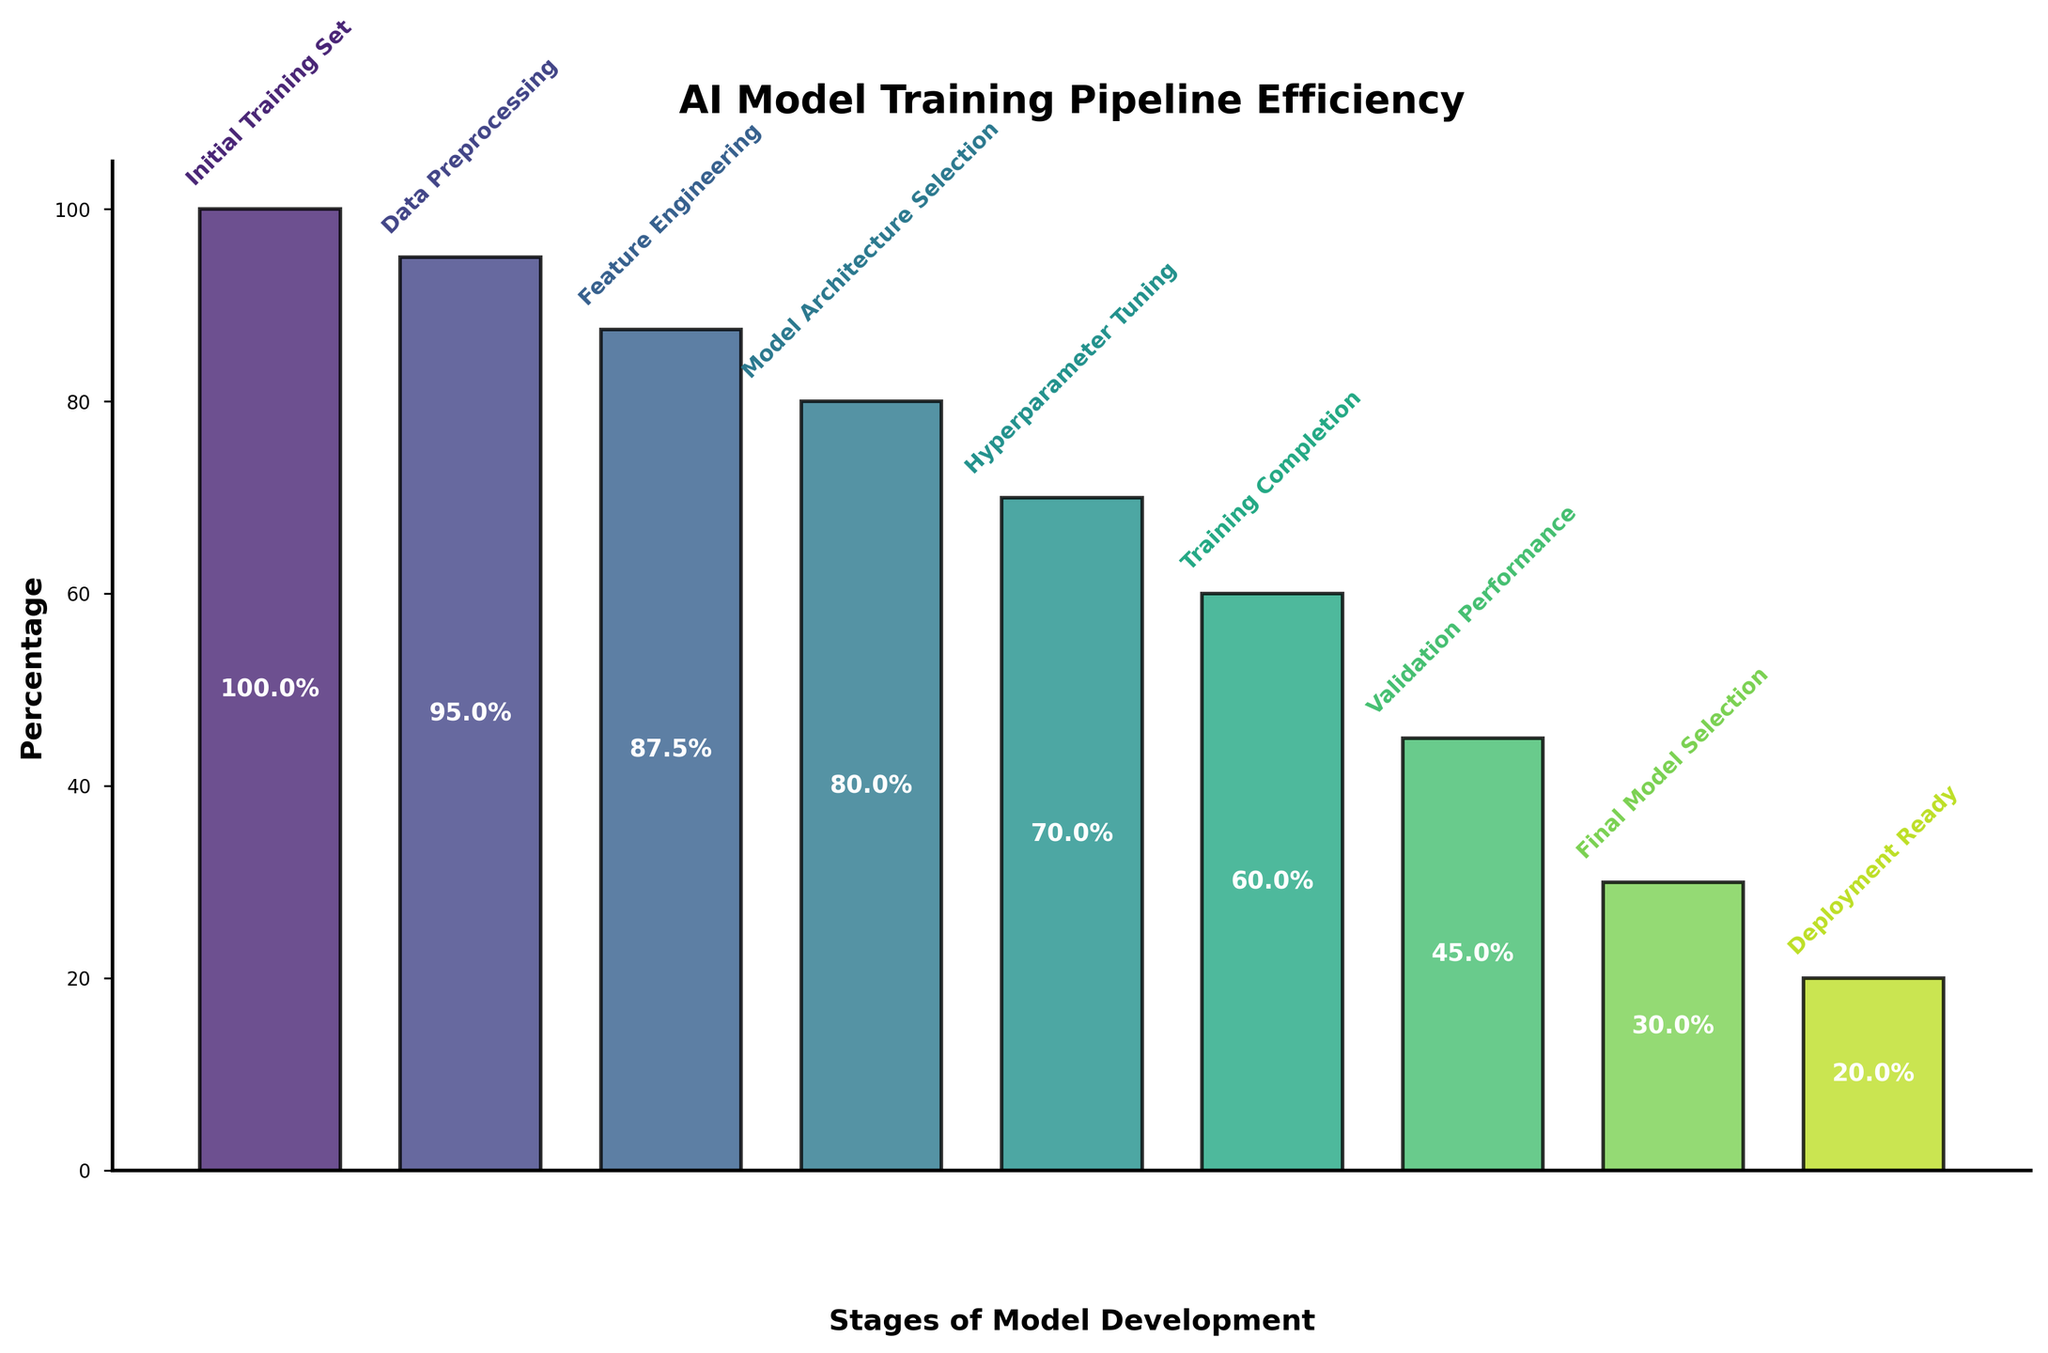What is the title of the figure? The figure's title is displayed prominently at the top of the plot, indicating the subject matter of the visual representation.
Answer: AI Model Training Pipeline Efficiency What stage has the highest percentage of models retained? The highest percentage is found at the first stage, as the bar representing this stage is the longest, indicating the largest number of models.
Answer: Initial Training Set What percentage of models are deployed ready? The percentage of models at the 'Deployment Ready' stage is depicted by the height of the bar corresponding to this stage.
Answer: 20% How many models are retained after Hyperparameter Tuning? The number of models retained is stated explicitly next to the corresponding stage on the figure.
Answer: 700 What is the difference in retention percentage between Model Architecture Selection and Validation Performance? The retention percentage at 'Model Architecture Selection' is 80%, and at 'Validation Performance' is 45%. The difference is calculated as 80% - 45%.
Answer: 35% Which stage shows the largest drop in the number of models, and by how much? By looking at the heights of the bars, the transition from 'Training Completion' (60%) to 'Validation Performance' (45%) shows the largest drop. The difference is calculated as 60% - 45%.
Answer: Training Completion to Validation Performance, 15% What is the average percentage retention across all stages? Sum all percentages (100% + 95% + 87.5% + 80% + 70% + 60% + 45% + 30% + 20%) and then divide by the number of stages (9). The sum is 587.5% and the average is 587.5% / 9.
Answer: 65.3% Compare the dropout rate between Data Preprocessing and Feature Engineering. Which stage has a higher dropout rate, and by how much? Data Preprocessing retention is 95%, and Feature Engineering retention is 87.5%. The dropout rate for Data Preprocessing is 100% - 95% = 5%, and for Feature Engineering it is 95% - 87.5% = 7.5%. Feature Engineering has a higher dropout rate by 7.5% - 5%.
Answer: Feature Engineering, 2.5% What logical pattern can be observed from the percentage drop across the stages? Analyzing the percentages sequentially from 'Initial Training Set' to 'Deployment Ready', the retention rates consistently drop at nearly every stage.
Answer: Consistent decline 